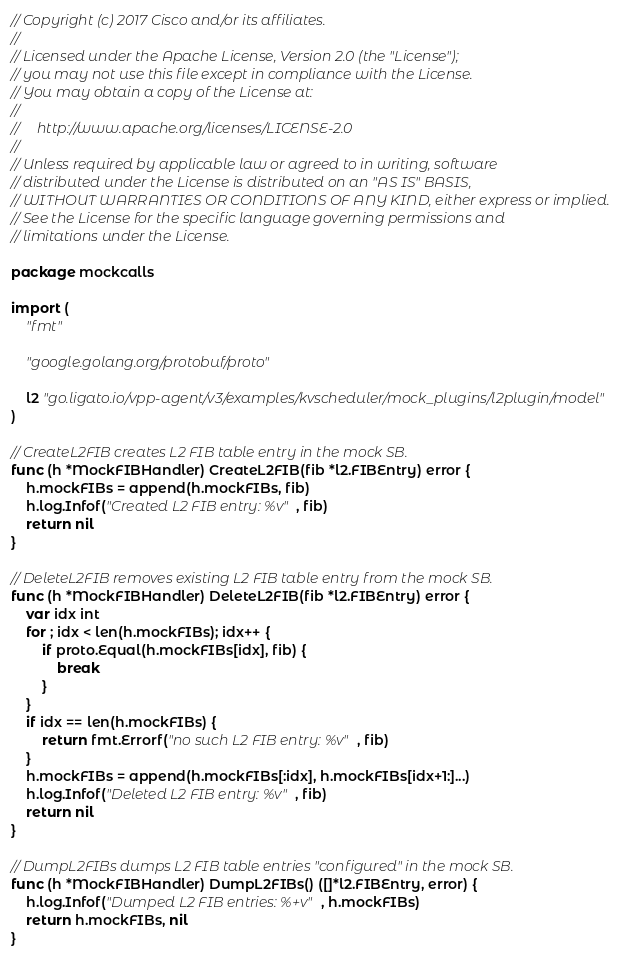<code> <loc_0><loc_0><loc_500><loc_500><_Go_>// Copyright (c) 2017 Cisco and/or its affiliates.
//
// Licensed under the Apache License, Version 2.0 (the "License");
// you may not use this file except in compliance with the License.
// You may obtain a copy of the License at:
//
//     http://www.apache.org/licenses/LICENSE-2.0
//
// Unless required by applicable law or agreed to in writing, software
// distributed under the License is distributed on an "AS IS" BASIS,
// WITHOUT WARRANTIES OR CONDITIONS OF ANY KIND, either express or implied.
// See the License for the specific language governing permissions and
// limitations under the License.

package mockcalls

import (
	"fmt"

	"google.golang.org/protobuf/proto"

	l2 "go.ligato.io/vpp-agent/v3/examples/kvscheduler/mock_plugins/l2plugin/model"
)

// CreateL2FIB creates L2 FIB table entry in the mock SB.
func (h *MockFIBHandler) CreateL2FIB(fib *l2.FIBEntry) error {
	h.mockFIBs = append(h.mockFIBs, fib)
	h.log.Infof("Created L2 FIB entry: %v", fib)
	return nil
}

// DeleteL2FIB removes existing L2 FIB table entry from the mock SB.
func (h *MockFIBHandler) DeleteL2FIB(fib *l2.FIBEntry) error {
	var idx int
	for ; idx < len(h.mockFIBs); idx++ {
		if proto.Equal(h.mockFIBs[idx], fib) {
			break
		}
	}
	if idx == len(h.mockFIBs) {
		return fmt.Errorf("no such L2 FIB entry: %v", fib)
	}
	h.mockFIBs = append(h.mockFIBs[:idx], h.mockFIBs[idx+1:]...)
	h.log.Infof("Deleted L2 FIB entry: %v", fib)
	return nil
}

// DumpL2FIBs dumps L2 FIB table entries "configured" in the mock SB.
func (h *MockFIBHandler) DumpL2FIBs() ([]*l2.FIBEntry, error) {
	h.log.Infof("Dumped L2 FIB entries: %+v", h.mockFIBs)
	return h.mockFIBs, nil
}
</code> 